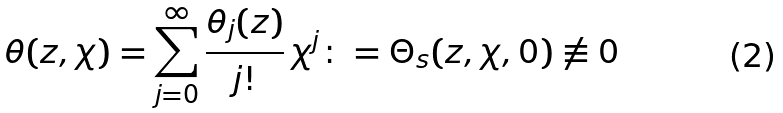<formula> <loc_0><loc_0><loc_500><loc_500>\theta ( z , \chi ) = \sum _ { j = 0 } ^ { \infty } \frac { \theta _ { j } ( z ) } { j ! } \, \chi ^ { j } \colon = \Theta _ { s } ( z , \chi , 0 ) \not \equiv 0</formula> 